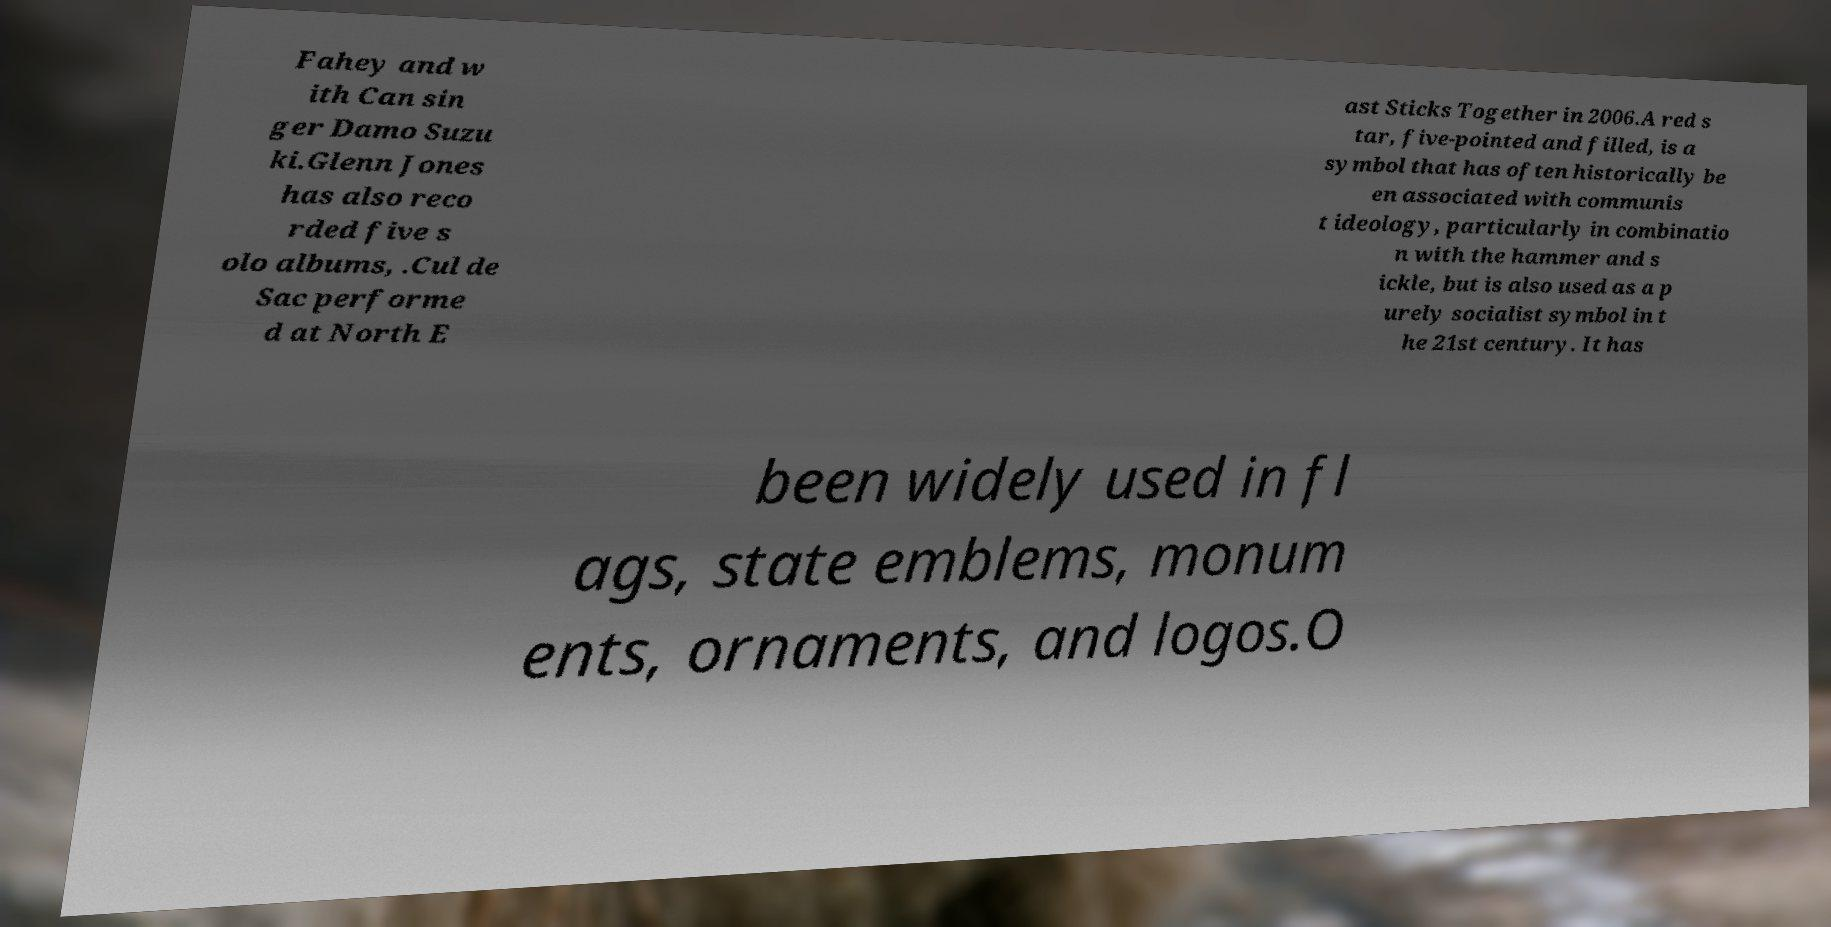Could you extract and type out the text from this image? Fahey and w ith Can sin ger Damo Suzu ki.Glenn Jones has also reco rded five s olo albums, .Cul de Sac performe d at North E ast Sticks Together in 2006.A red s tar, five-pointed and filled, is a symbol that has often historically be en associated with communis t ideology, particularly in combinatio n with the hammer and s ickle, but is also used as a p urely socialist symbol in t he 21st century. It has been widely used in fl ags, state emblems, monum ents, ornaments, and logos.O 